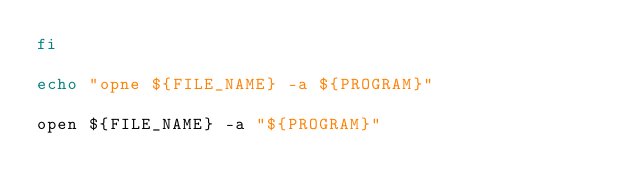<code> <loc_0><loc_0><loc_500><loc_500><_Bash_>fi

echo "opne ${FILE_NAME} -a ${PROGRAM}"

open ${FILE_NAME} -a "${PROGRAM}"</code> 